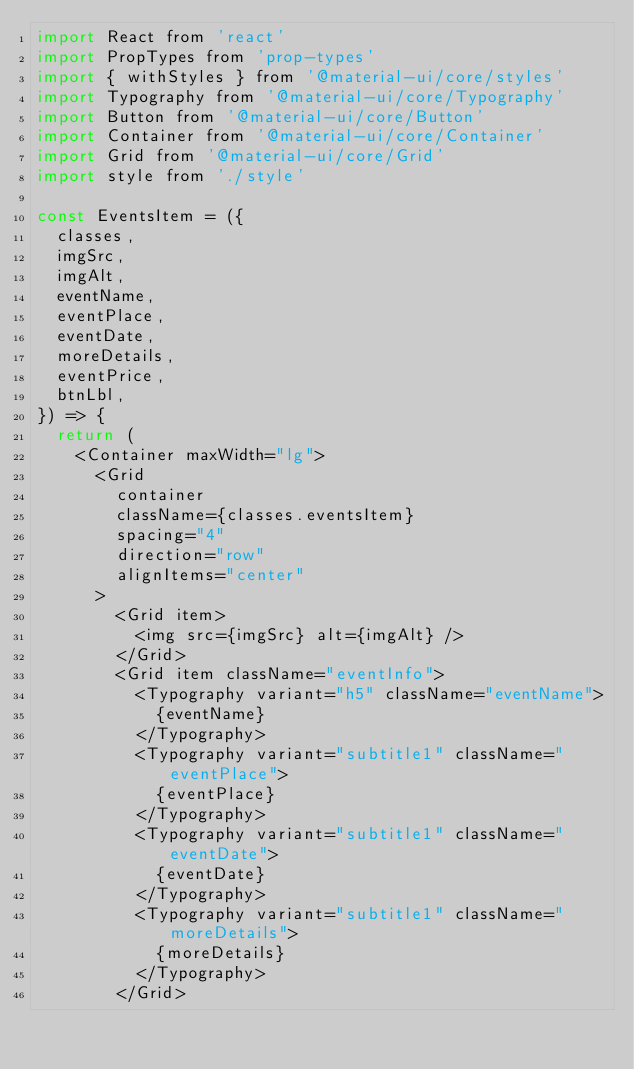Convert code to text. <code><loc_0><loc_0><loc_500><loc_500><_JavaScript_>import React from 'react'
import PropTypes from 'prop-types'
import { withStyles } from '@material-ui/core/styles'
import Typography from '@material-ui/core/Typography'
import Button from '@material-ui/core/Button'
import Container from '@material-ui/core/Container'
import Grid from '@material-ui/core/Grid'
import style from './style'

const EventsItem = ({
  classes,
  imgSrc,
  imgAlt,
  eventName,
  eventPlace,
  eventDate,
  moreDetails,
  eventPrice,
  btnLbl,
}) => {
  return (
    <Container maxWidth="lg">
      <Grid
        container
        className={classes.eventsItem}
        spacing="4"
        direction="row"
        alignItems="center"
      >
        <Grid item>
          <img src={imgSrc} alt={imgAlt} />
        </Grid>
        <Grid item className="eventInfo">
          <Typography variant="h5" className="eventName">
            {eventName}
          </Typography>
          <Typography variant="subtitle1" className="eventPlace">
            {eventPlace}
          </Typography>
          <Typography variant="subtitle1" className="eventDate">
            {eventDate}
          </Typography>
          <Typography variant="subtitle1" className="moreDetails">
            {moreDetails}
          </Typography>
        </Grid></code> 